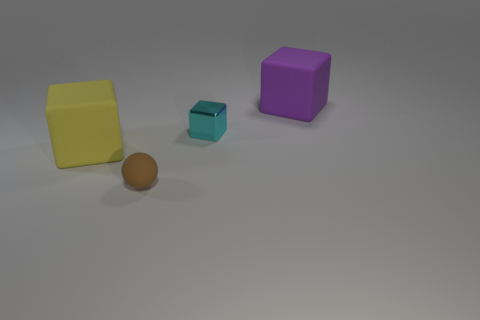What color is the big object that is on the right side of the object that is in front of the large yellow matte block? The big object to the right of the small turquoise block, which itself is in front of the large yellow matte block, is purple. 